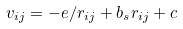<formula> <loc_0><loc_0><loc_500><loc_500>v _ { i j } = - e / r _ { i j } + b _ { s } r _ { i j } + c</formula> 